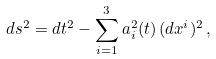Convert formula to latex. <formula><loc_0><loc_0><loc_500><loc_500>d s ^ { 2 } = d t ^ { 2 } - \sum _ { i = 1 } ^ { 3 } a _ { i } ^ { 2 } ( t ) \, ( d x ^ { i } ) ^ { 2 } \, ,</formula> 